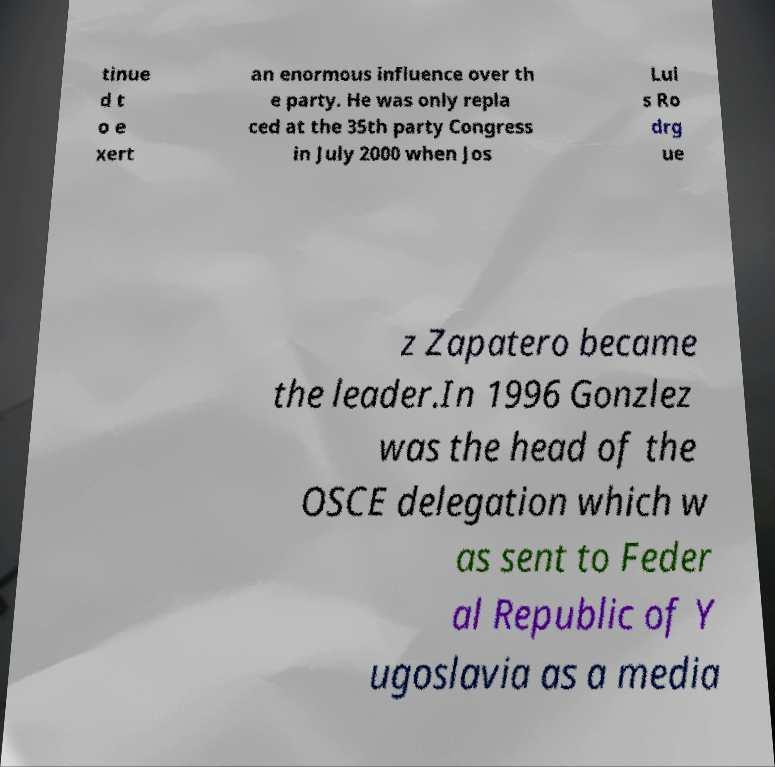Could you extract and type out the text from this image? tinue d t o e xert an enormous influence over th e party. He was only repla ced at the 35th party Congress in July 2000 when Jos Lui s Ro drg ue z Zapatero became the leader.In 1996 Gonzlez was the head of the OSCE delegation which w as sent to Feder al Republic of Y ugoslavia as a media 